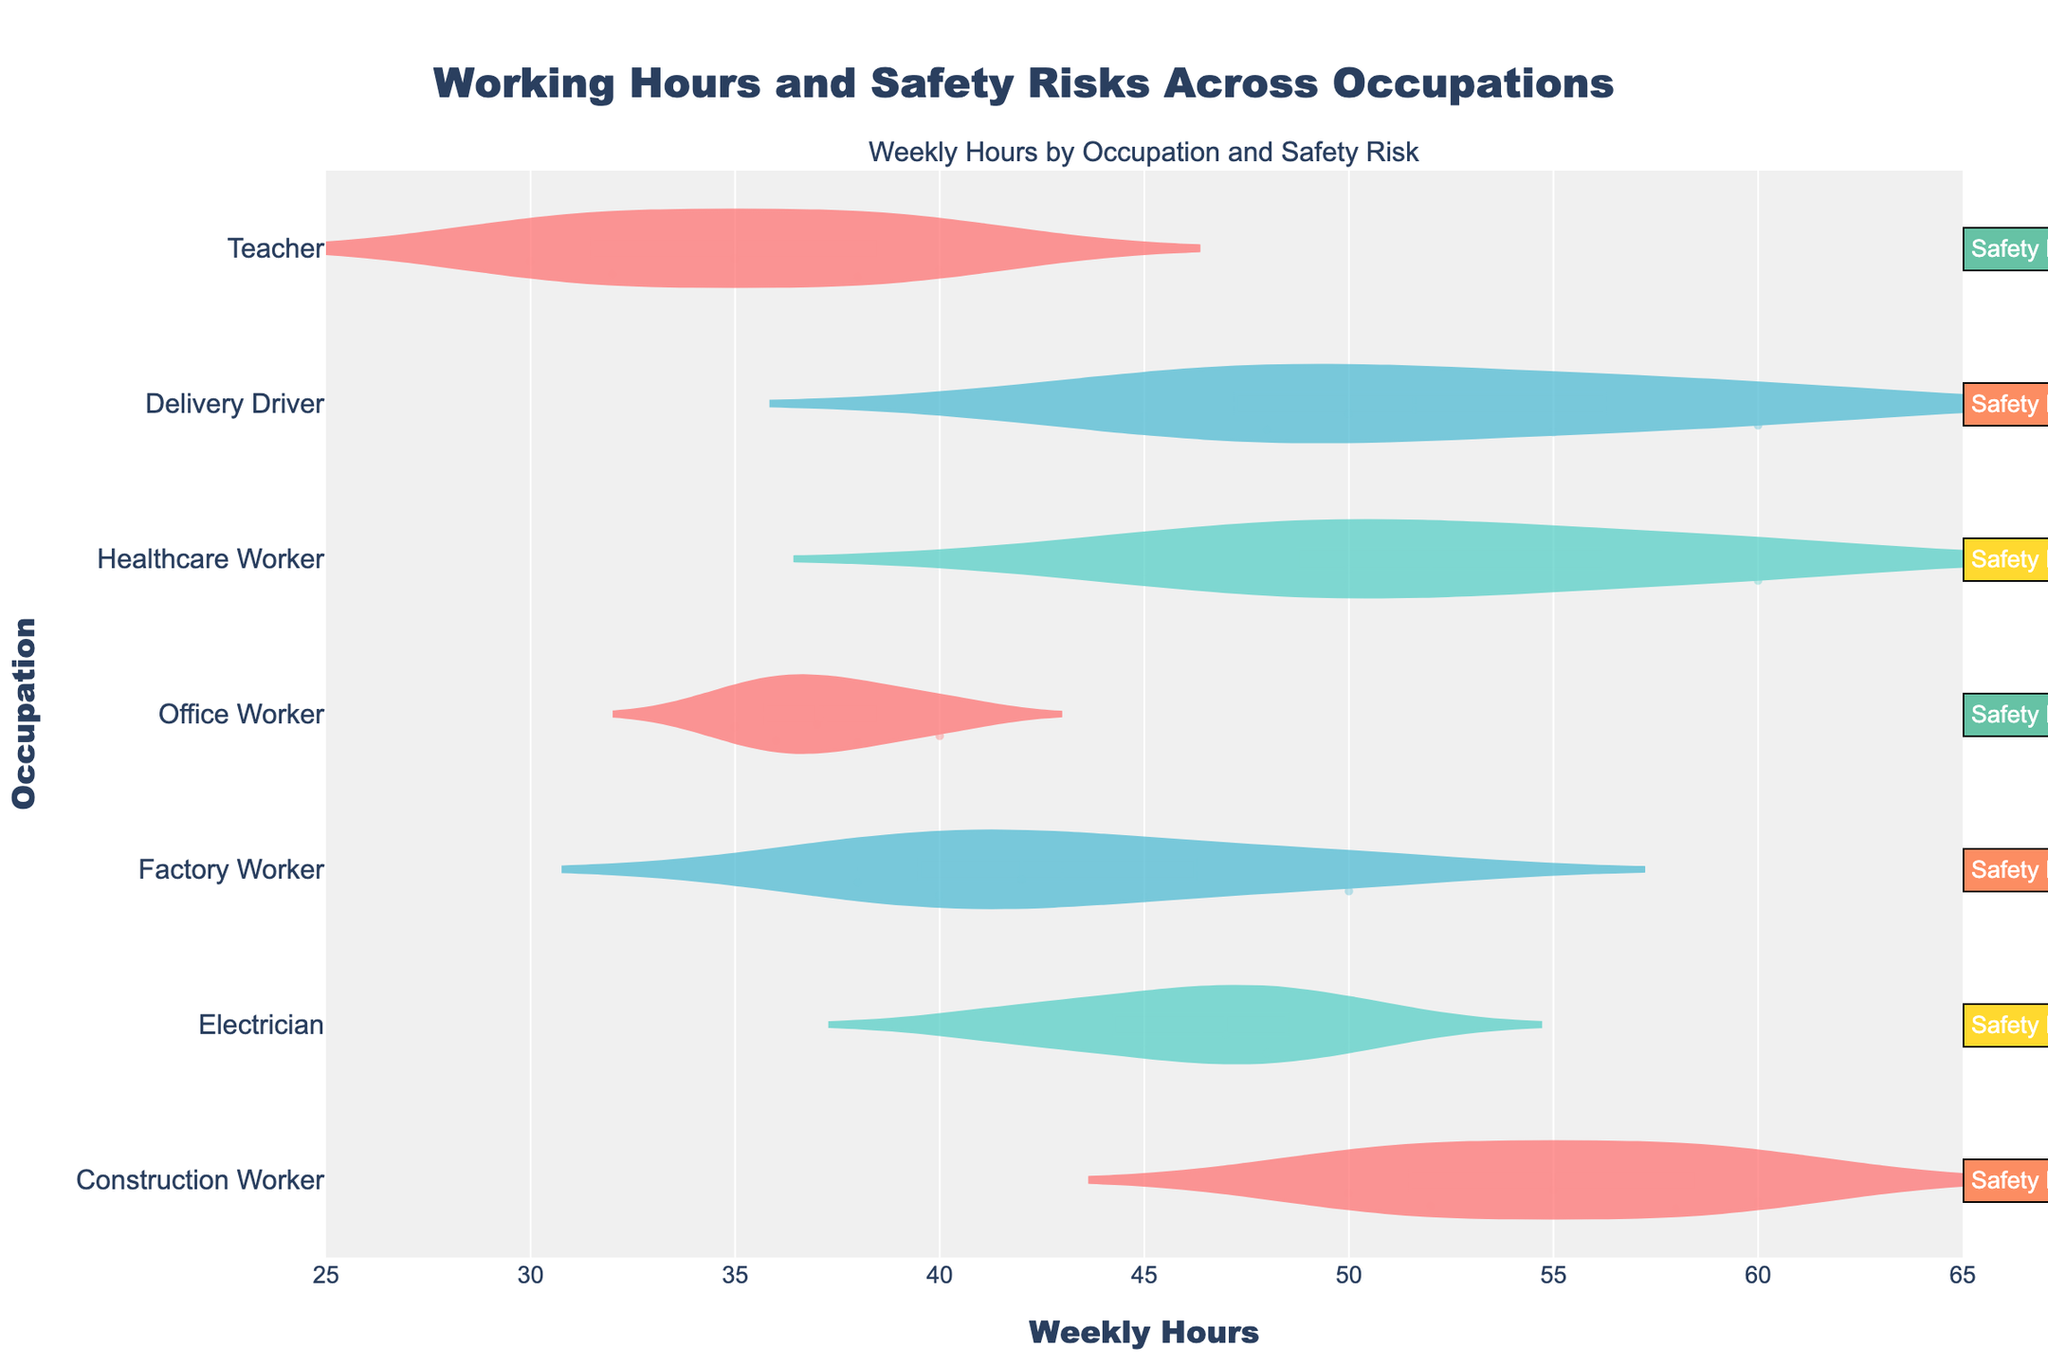What is the title of the figure? The title of the figure is located at the top and is usually styled in a larger, bold font. In this case, you'll find the title reads 'Working Hours and Safety Risks Across Occupations.'
Answer: Working Hours and Safety Risks Across Occupations What does the x-axis represent? The x-axis typically represents numerical data in the horizontal direction. Here, it is labeled 'Weekly Hours' indicating the number of hours worked per week.
Answer: Weekly Hours Which occupation has the highest median weekly work hours? To determine the median, look for the line within the "box" of each violin plot, which typically represents median value. By comparing, Construction Worker and Healthcare Worker both show higher medians at around 50 hours.
Answer: Construction Worker and Healthcare Worker What is the safety risk level for Electricians? The safety risk level is annotated to the right of each occupation on the plot. According to the annotation next to Electrician, the risk level is Medium.
Answer: Medium What is the range of weekly hours for Office Workers? To find the range, observe the spread of the violin plot for Office Workers on the x-axis. The range spans from approximately 35 to 40 weekly hours.
Answer: 35 to 40 How many occupations have a high workplace safety risk? Look at the annotations and count the number annotated with "High" safety risk. The occupations listed as High safety risk are Construction Worker, Factory Worker, and Delivery Driver, making it three occupations.
Answer: Three Which occupation has the widest distribution of weekly hours? Look at the width and spread of each violin plot along the x-axis. The Construction Worker and Healthcare Worker plots show the widest spreads, ranging from 45 to 60 hours, but the Construction Worker plot appears slightly wider.
Answer: Construction Worker Do Teachers generally work more or fewer weekly hours compared to Office Workers? Compare the central parts (boxes and median lines) of the Teacher and Office Worker violin plots. Teachers typically work fewer hours in the range of 30-40 compared to Office Workers who work closer to 35-40 hours.
Answer: Fewer How many different safety risk levels are represented in the plot? Each unique safety risk level is annotated to the right of the plot and color-coded differently. The listed safety risk levels are High, Medium, and Low, making a total of three different levels.
Answer: Three Which occupation has the smallest range of weekly work hours? To determine the smallest range, look at the violin plots and find the one with the least spread. The Office Worker plot shows the smallest range from approximately 35 to 40 hours.
Answer: Office Worker 